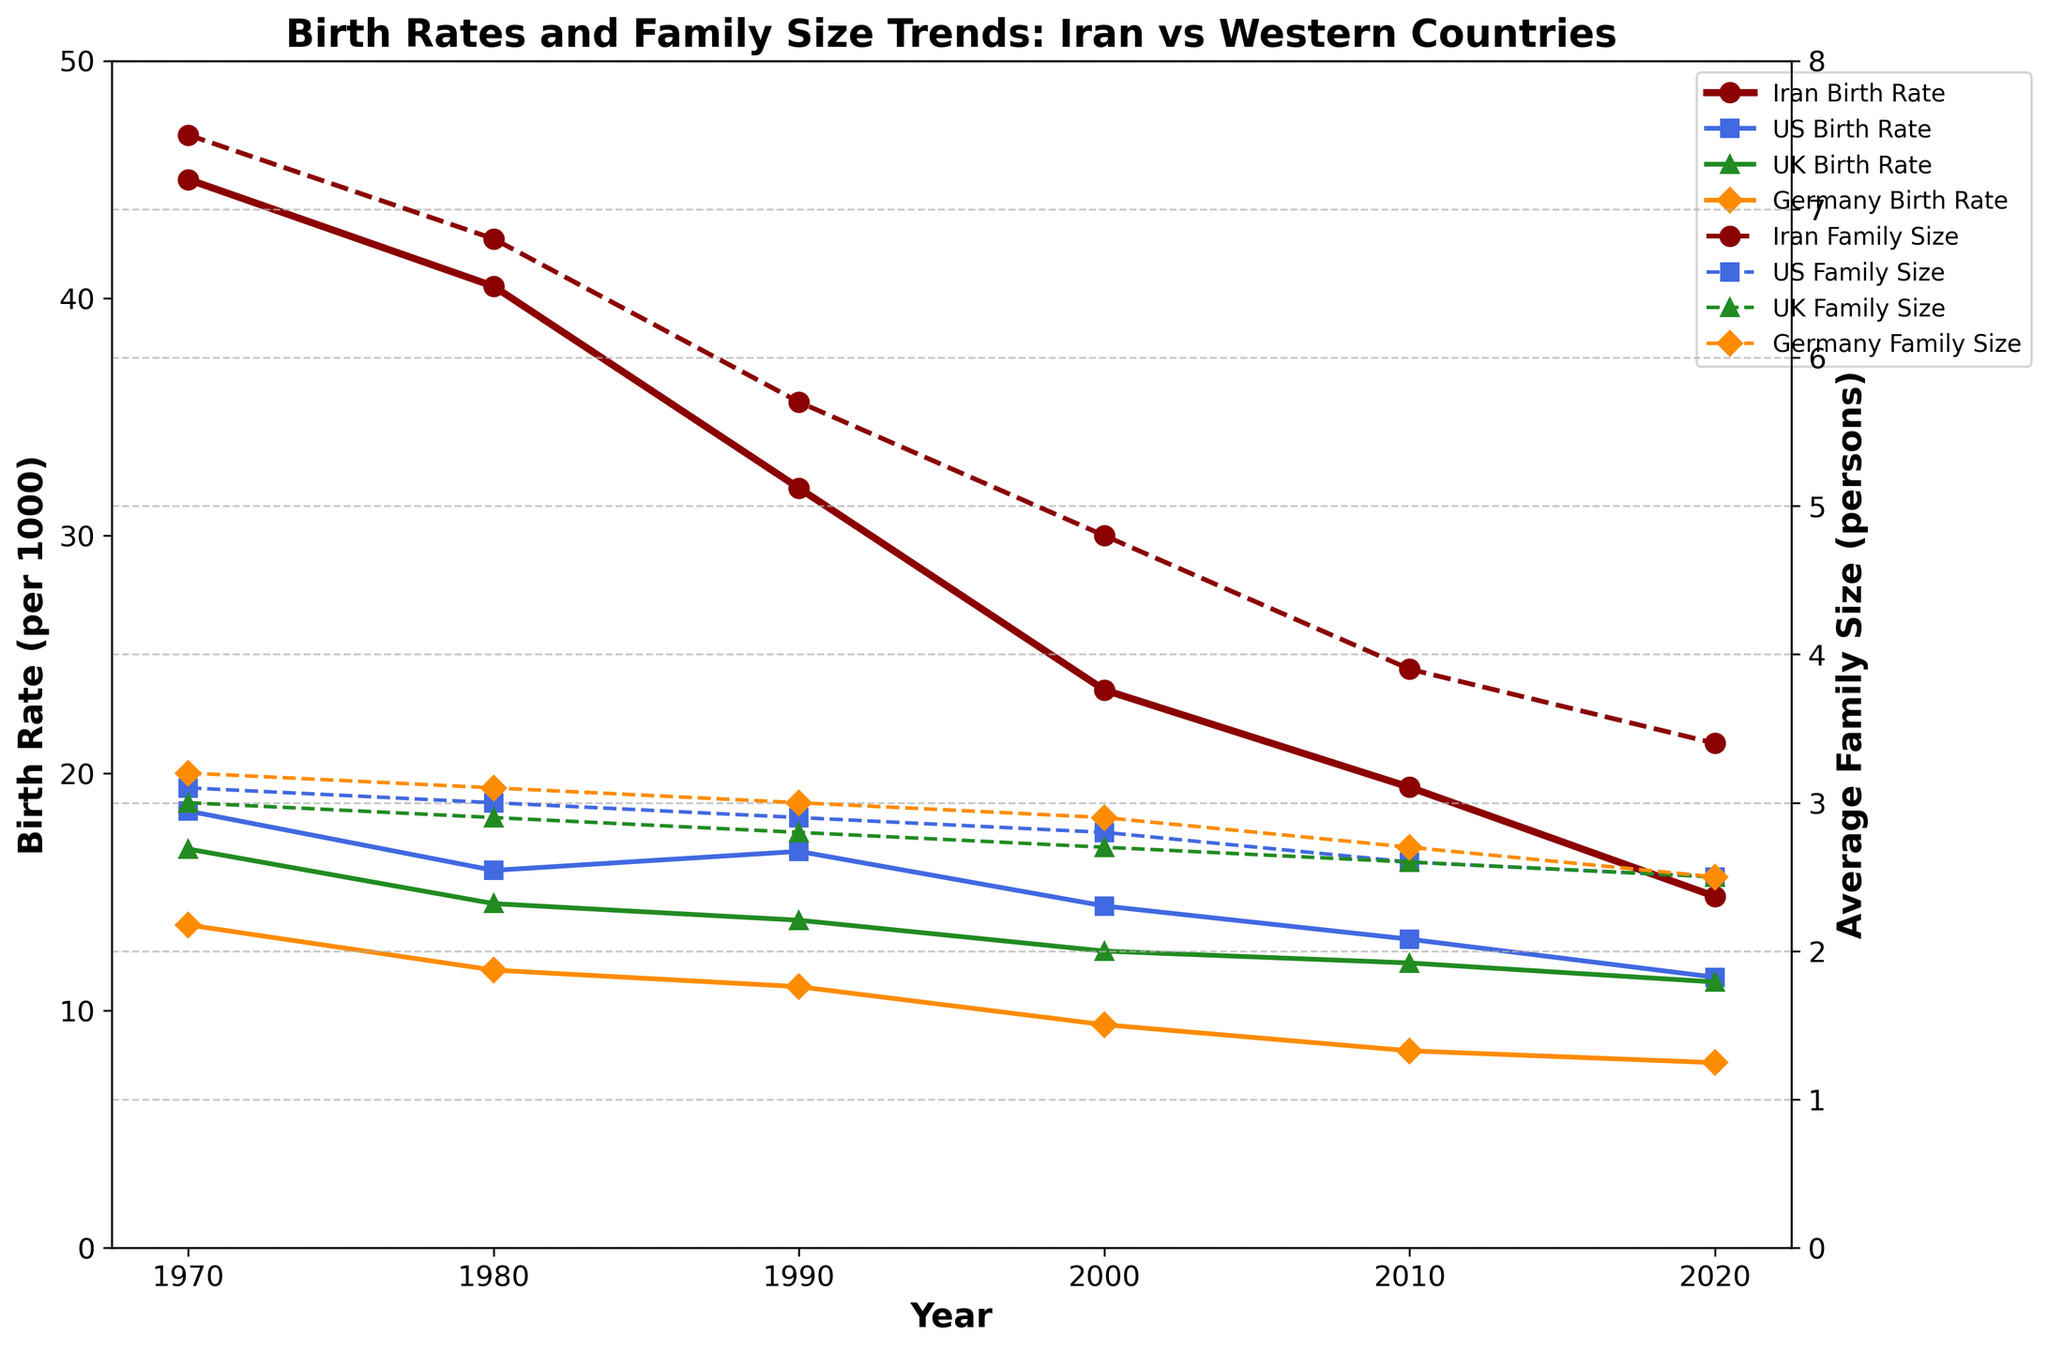What is the title of the figure? The title of the figure is prominently displayed at the top of the plot.
Answer: Birth Rates and Family Size Trends: Iran vs Western Countries What is the trend in Iran's birth rate from 1970 to 2020? To determine the trend, examine the line representing Iran's birth rate over the years, noting the overall direction. It decreases from 45.0 in 1970 to 14.8 in 2020.
Answer: Decreasing How does Iran's average family size in 1970 compare to that in 2020? Look at the data points for Iran's average family size in 1970 and 2020. It starts at 7.5 in 1970 and drops to 3.4 in 2020.
Answer: It decreased from 7.5 to 3.4 Which country had the highest birth rate in 1980? Compare the birth rates of Iran, the US, the UK, and Germany in 1980. Iran has the highest at 40.5.
Answer: Iran In which year did the US birth rate show a notable decrease compared to the previous decade? Compare the birth rates for consecutive decades. There is a notable decrease from 18.4 in 1970 to 15.9 in 1980.
Answer: 1980 What is the difference in average family size between Iran and the US in 2020? Subtract the US family size (2.5) from Iran's family size (3.4) in 2020.
Answer: 0.9 How do the birth rates of the UK and Germany in 1990 compare? Check the data points for UK and Germany in 1990. The UK has a birth rate of 13.8, while Germany's is 11.0.
Answer: The UK's birth rate is higher What was the average birth rate in Iran in the 2000s? Find the average by summing the birth rates of Iran in 2000 and 2010, then divide by 2. (23.5 + 19.4) / 2 = 21.45
Answer: 21.45 Between which years did Iran see the most significant drop in birth rate? Inspect the data points for Iran across the years. The most significant drop is between 1980 (40.5) and 1990 (32.0), a difference of 8.5.
Answer: 1980 to 1990 How does the trend in family size in Western countries compare to that in Iran over the 50-year period? Examine the trends for family sizes in Western countries (US, UK, Germany) and compare them with Iran's trend. Both show a decreasing trend, but Iran's reduction is more steep.
Answer: Both decreasing, Iran's is steeper 